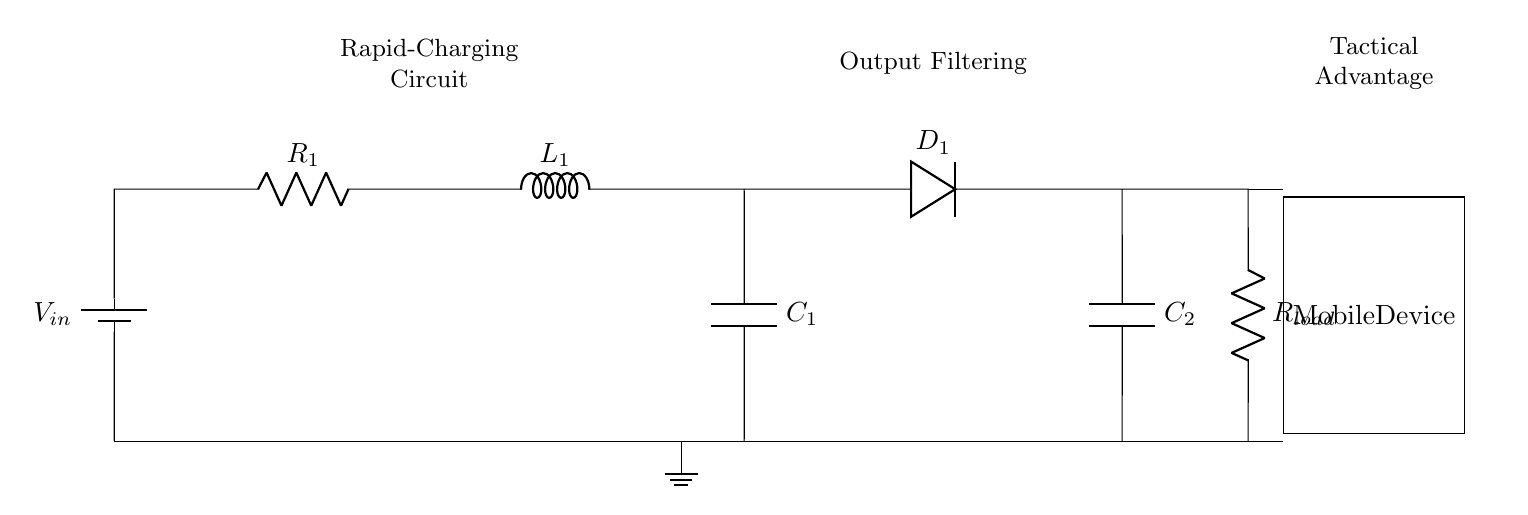What is the input voltage of the circuit? The input voltage is represented as V in the circuit diagram. It is typically supplied by a battery.
Answer: V in What do R1 and Rload have in common? R1 and Rload are both resistive components found in the circuit. R1 is part of the charging mechanism, while Rload is the load that the circuit drives.
Answer: Both are resistors What is the purpose of the inductor L1? The inductor L1 is generally used for energy storage and filtering in charging circuits, smoothing the current delivered to the load.
Answer: Energy storage What types of components are C1 and C2? C1 and C2 are capacitors used in the circuit for filtering and energy storage. They help stabilize voltage and reduce ripples in the output.
Answer: Capacitors How does the presence of D1 affect the circuit? The diode D1 allows current to flow in one direction only, enabling charging of the capacitors while preventing backflow, which protects the circuit from reverse polarity.
Answer: Allows unidirectional flow Which component is directly connected to the mobile device? The components connected directly to the mobile device are Rload, C2, and the connections leading to the mobile device itself.
Answer: Rload, C2 What is the role of the output filtering section? The output filtering section, including C2, regulates and smoothens the output voltage to the mobile device, ensuring stable power delivery.
Answer: Regulates voltage 